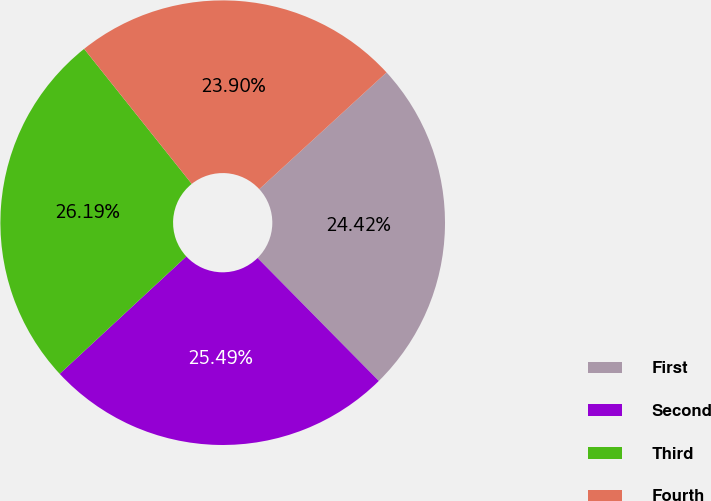Convert chart to OTSL. <chart><loc_0><loc_0><loc_500><loc_500><pie_chart><fcel>First<fcel>Second<fcel>Third<fcel>Fourth<nl><fcel>24.42%<fcel>25.49%<fcel>26.19%<fcel>23.9%<nl></chart> 